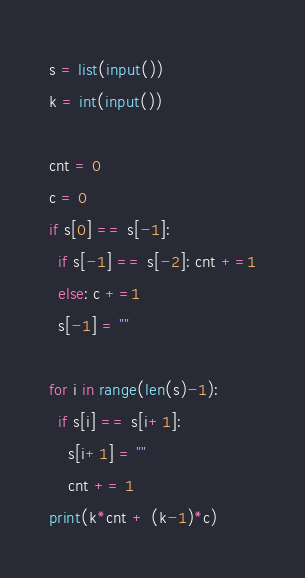Convert code to text. <code><loc_0><loc_0><loc_500><loc_500><_Python_>s = list(input())
k = int(input())

cnt = 0
c = 0
if s[0] == s[-1]:
  if s[-1] == s[-2]: cnt +=1
  else: c +=1
  s[-1] = ""

for i in range(len(s)-1):
  if s[i] == s[i+1]:
    s[i+1] = ""
    cnt += 1
print(k*cnt + (k-1)*c)</code> 